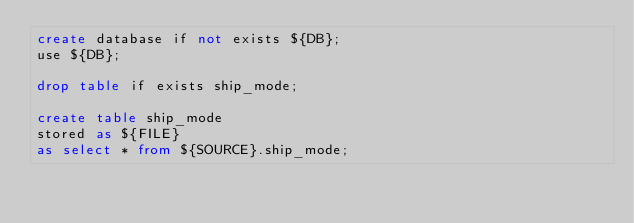<code> <loc_0><loc_0><loc_500><loc_500><_SQL_>create database if not exists ${DB};
use ${DB};

drop table if exists ship_mode;

create table ship_mode
stored as ${FILE}
as select * from ${SOURCE}.ship_mode;
</code> 